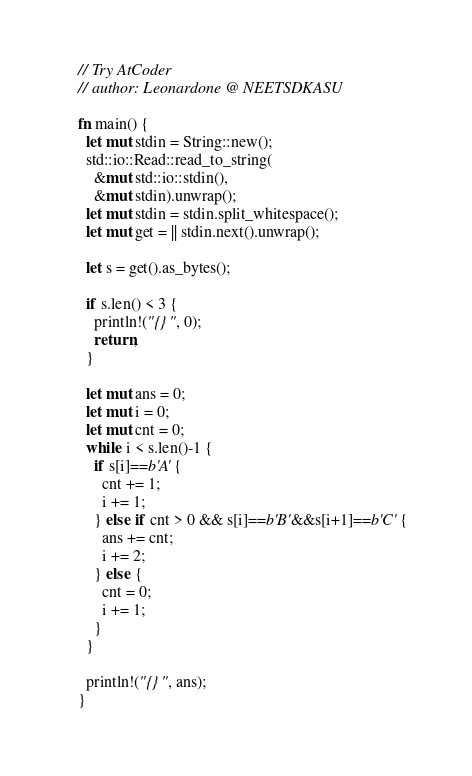<code> <loc_0><loc_0><loc_500><loc_500><_Rust_>// Try AtCoder
// author: Leonardone @ NEETSDKASU

fn main() {
  let mut stdin = String::new();
  std::io::Read::read_to_string(
    &mut std::io::stdin(),
    &mut stdin).unwrap();
  let mut stdin = stdin.split_whitespace();
  let mut get = || stdin.next().unwrap();
  
  let s = get().as_bytes();
  
  if s.len() < 3 {
    println!("{}", 0);
    return;
  }
  
  let mut ans = 0;
  let mut i = 0;
  let mut cnt = 0;
  while i < s.len()-1 {
    if s[i]==b'A' {
      cnt += 1;
      i += 1;
    } else if cnt > 0 && s[i]==b'B'&&s[i+1]==b'C' {
      ans += cnt;
      i += 2;
    } else {
      cnt = 0;
      i += 1;
    }
  }
  
  println!("{}", ans);
}</code> 